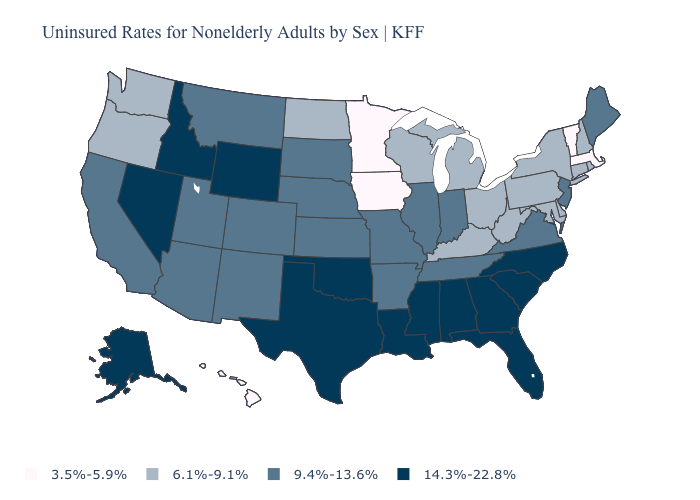Name the states that have a value in the range 9.4%-13.6%?
Quick response, please. Arizona, Arkansas, California, Colorado, Illinois, Indiana, Kansas, Maine, Missouri, Montana, Nebraska, New Jersey, New Mexico, South Dakota, Tennessee, Utah, Virginia. Name the states that have a value in the range 6.1%-9.1%?
Give a very brief answer. Connecticut, Delaware, Kentucky, Maryland, Michigan, New Hampshire, New York, North Dakota, Ohio, Oregon, Pennsylvania, Rhode Island, Washington, West Virginia, Wisconsin. Does Massachusetts have a higher value than Pennsylvania?
Short answer required. No. What is the value of Kentucky?
Answer briefly. 6.1%-9.1%. Does the map have missing data?
Answer briefly. No. What is the value of Wyoming?
Answer briefly. 14.3%-22.8%. What is the value of Vermont?
Be succinct. 3.5%-5.9%. Does Illinois have the same value as South Carolina?
Keep it brief. No. Name the states that have a value in the range 6.1%-9.1%?
Answer briefly. Connecticut, Delaware, Kentucky, Maryland, Michigan, New Hampshire, New York, North Dakota, Ohio, Oregon, Pennsylvania, Rhode Island, Washington, West Virginia, Wisconsin. Which states have the lowest value in the Northeast?
Keep it brief. Massachusetts, Vermont. Name the states that have a value in the range 3.5%-5.9%?
Keep it brief. Hawaii, Iowa, Massachusetts, Minnesota, Vermont. Name the states that have a value in the range 3.5%-5.9%?
Give a very brief answer. Hawaii, Iowa, Massachusetts, Minnesota, Vermont. Name the states that have a value in the range 9.4%-13.6%?
Answer briefly. Arizona, Arkansas, California, Colorado, Illinois, Indiana, Kansas, Maine, Missouri, Montana, Nebraska, New Jersey, New Mexico, South Dakota, Tennessee, Utah, Virginia. Does Kentucky have the lowest value in the USA?
Quick response, please. No. Which states have the lowest value in the USA?
Quick response, please. Hawaii, Iowa, Massachusetts, Minnesota, Vermont. 